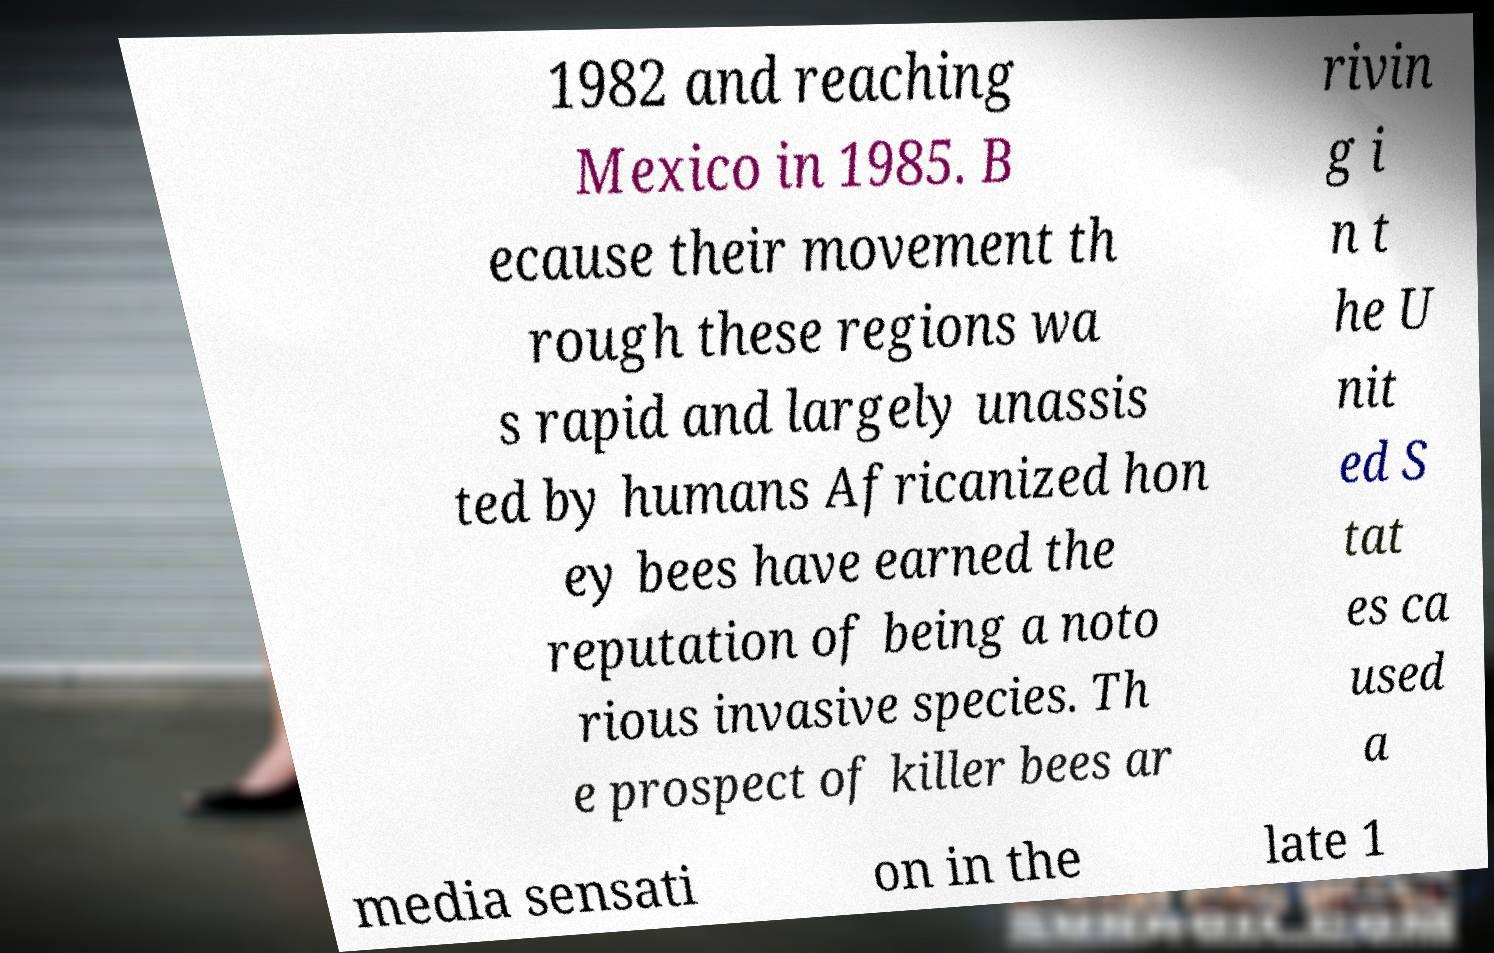For documentation purposes, I need the text within this image transcribed. Could you provide that? 1982 and reaching Mexico in 1985. B ecause their movement th rough these regions wa s rapid and largely unassis ted by humans Africanized hon ey bees have earned the reputation of being a noto rious invasive species. Th e prospect of killer bees ar rivin g i n t he U nit ed S tat es ca used a media sensati on in the late 1 